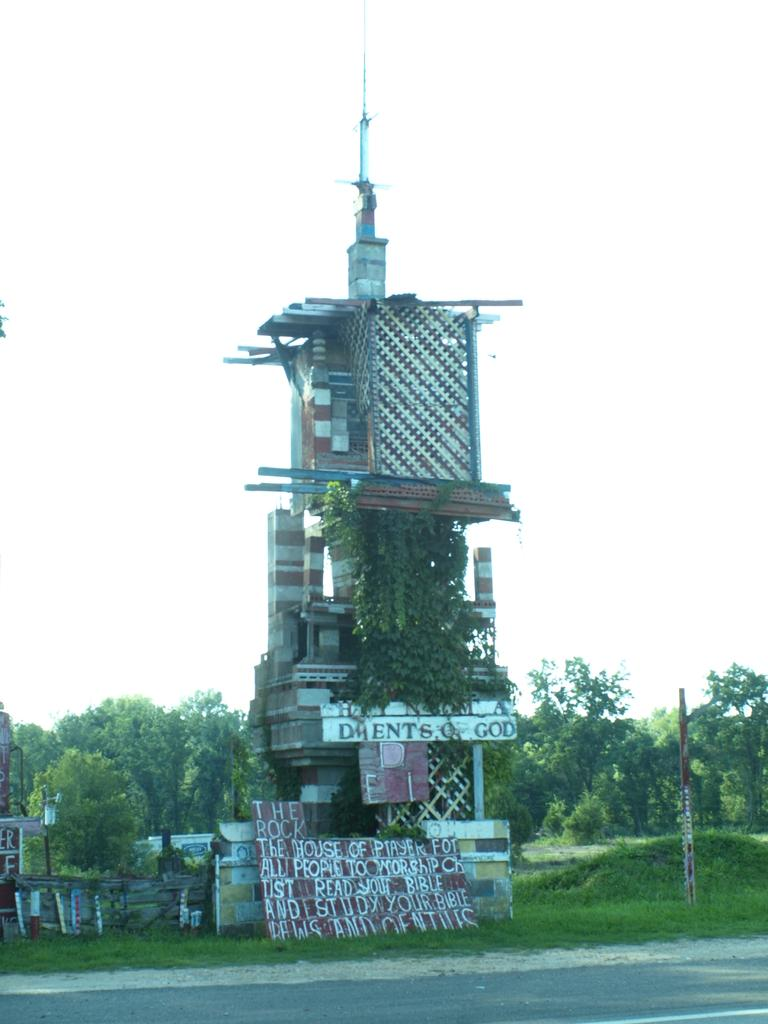What is located in the front of the image? There is a road in the front of the image. What can be seen in the background of the image? In the background of the image, there is grass, a tower, boards with writing, and trees. Can you describe the tower in the background? The tower is visible in the background of the image. What type of vegetation is present in the background? There are trees in the background of the image. Can you see a wren perched on the tower in the image? There is no wren present in the image. What color is the tongue of the person in the image? There is no person present in the image, so it is not possible to determine the color of their tongue. 